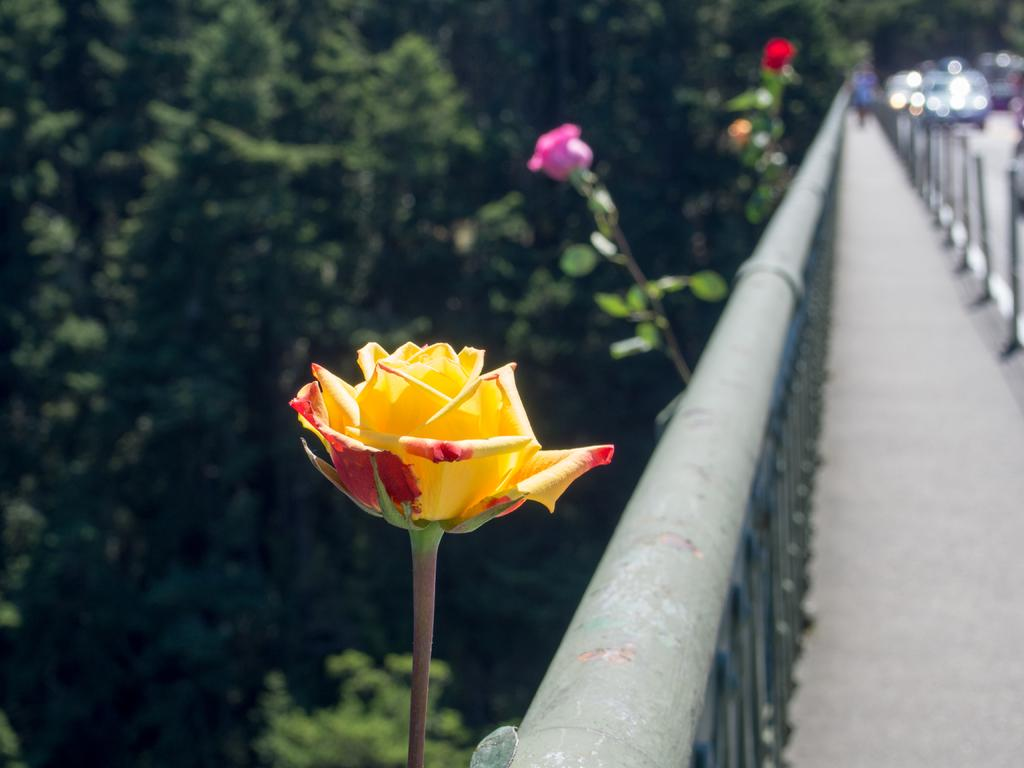What is the main structure visible in the image? There is a bridge in the image. Are there any plants or flowers near the bridge? Yes, there are beautiful roses beside the bridge. Can you describe the background of the image? The background of the image is blurry. How many divisions can be seen in the volcano in the image? There is no volcano present in the image. Can you count the number of kittens playing on the bridge in the image? There are no kittens present in the image. 